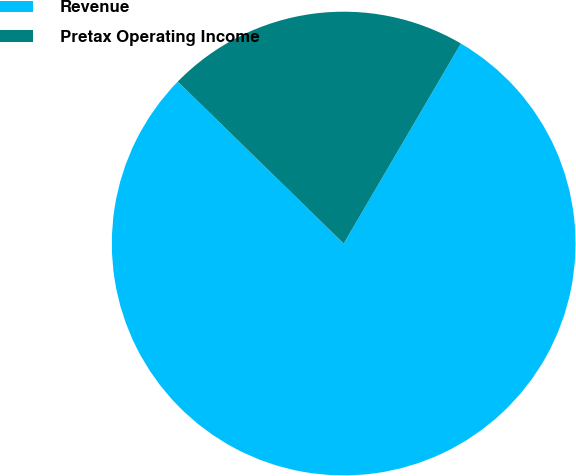Convert chart to OTSL. <chart><loc_0><loc_0><loc_500><loc_500><pie_chart><fcel>Revenue<fcel>Pretax Operating Income<nl><fcel>78.87%<fcel>21.13%<nl></chart> 